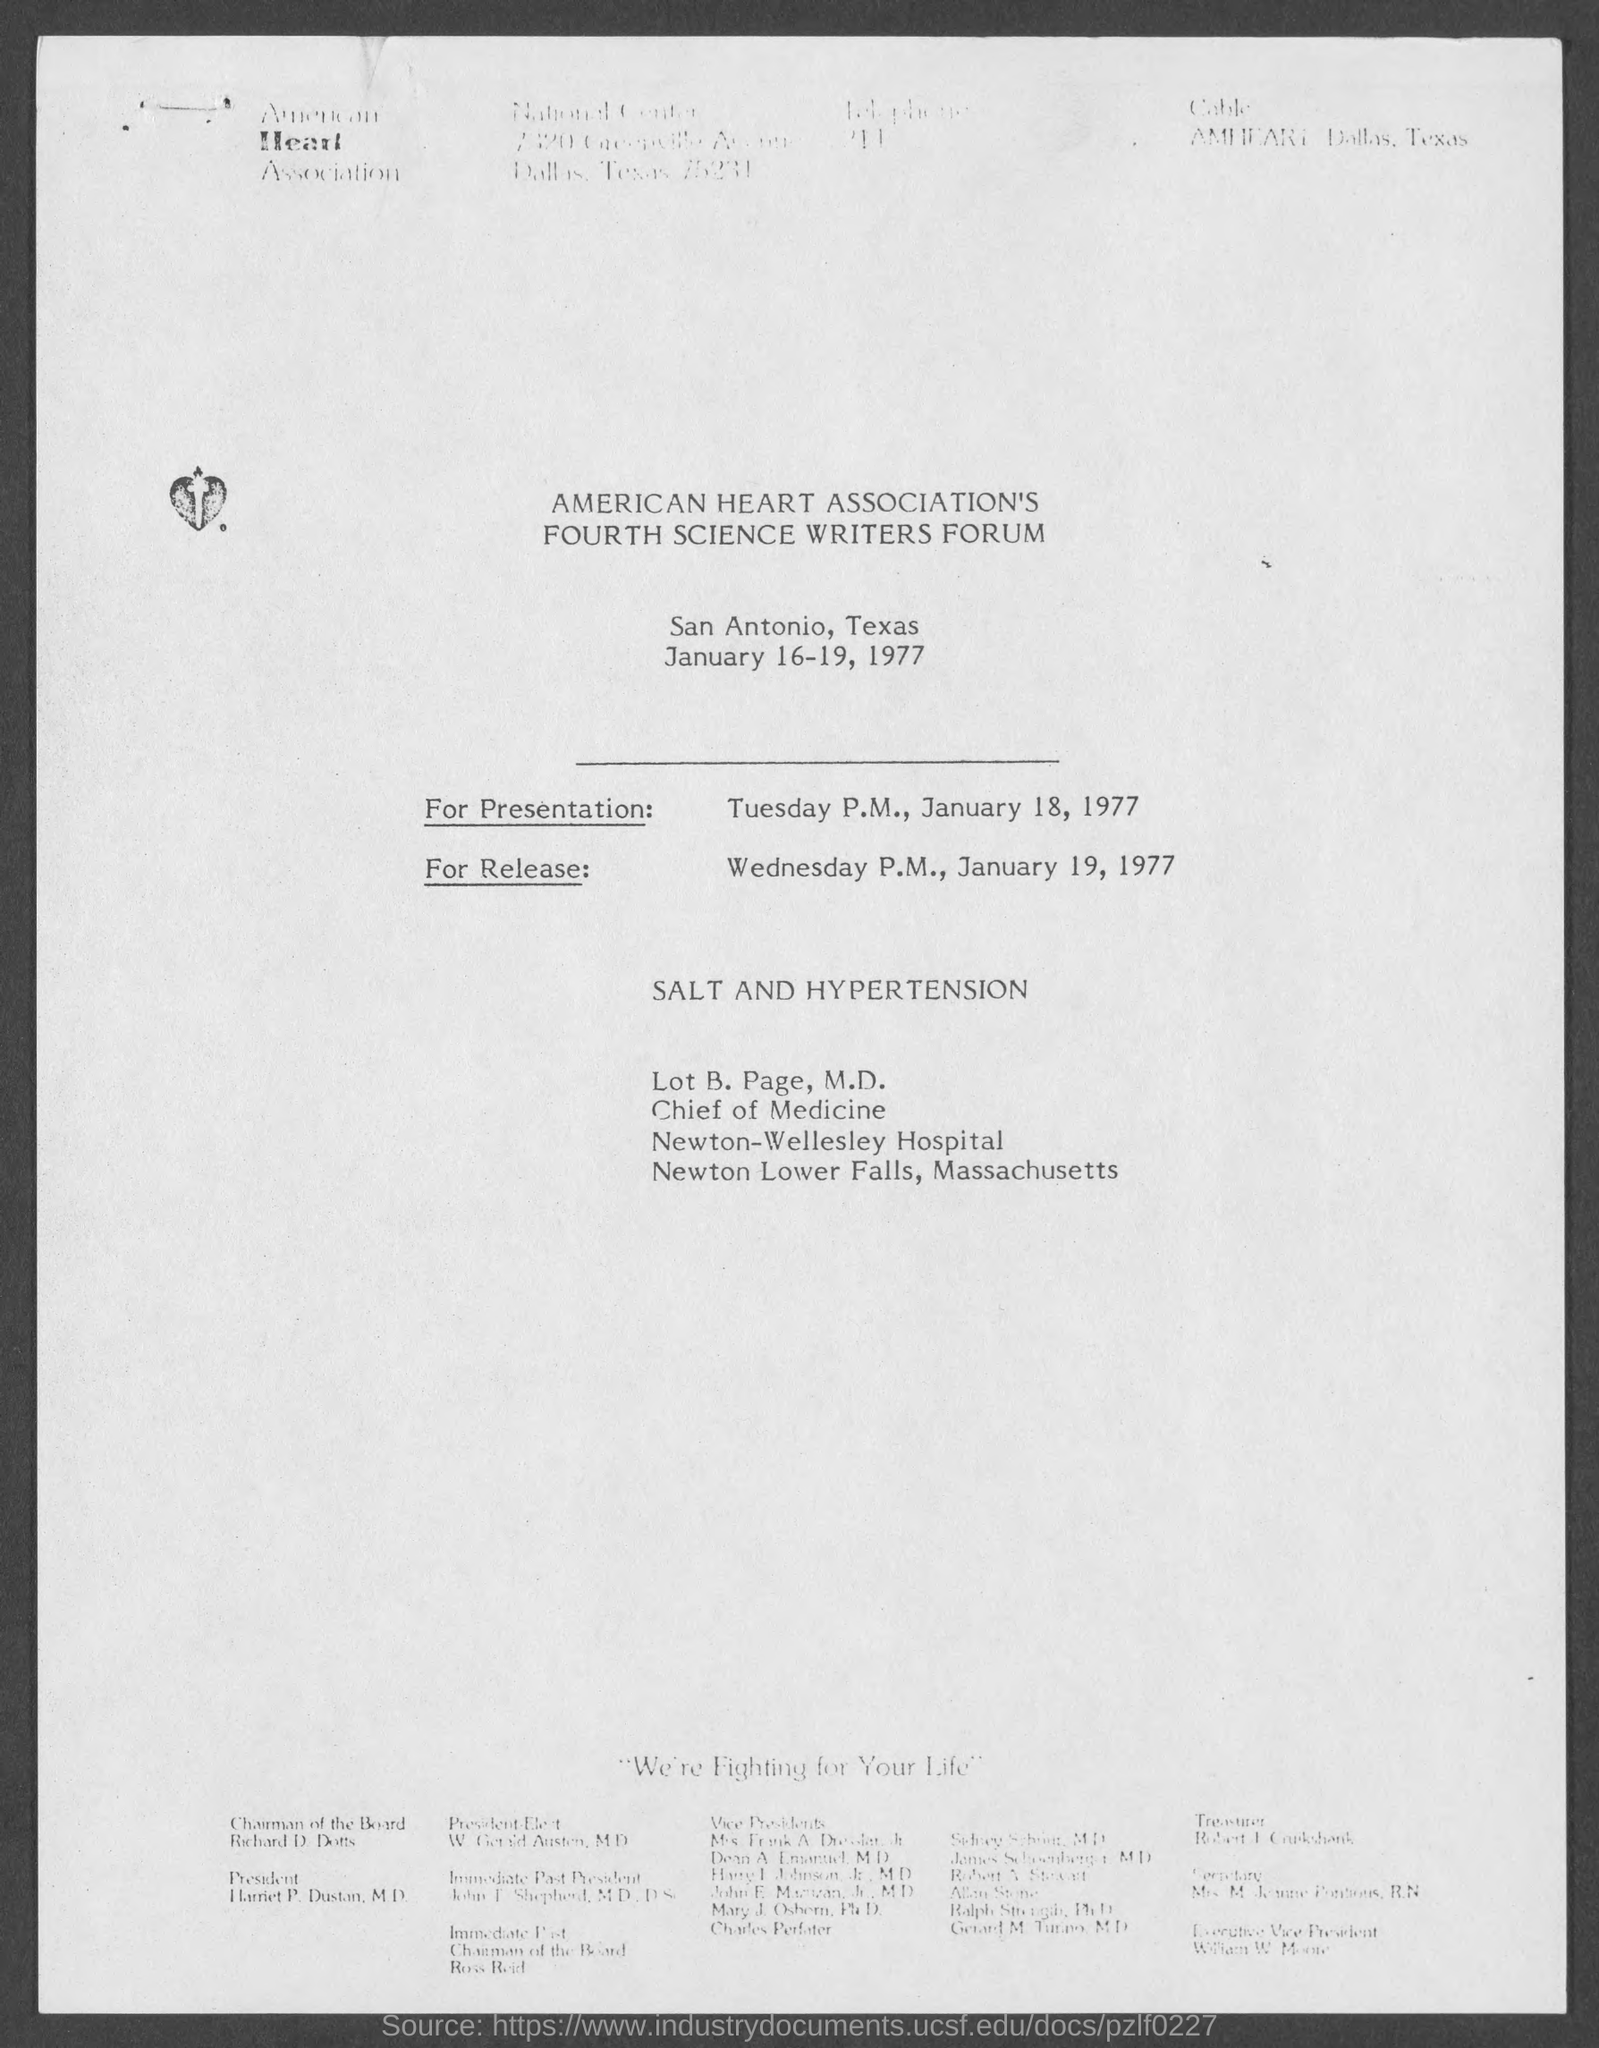Specify some key components in this picture. The American Heart Association's Fourth Science Writers Forum was held in San Antonio, Texas. The American Heart Association's Fourth Science Writers Forum was held on January 16-19, 1977. 